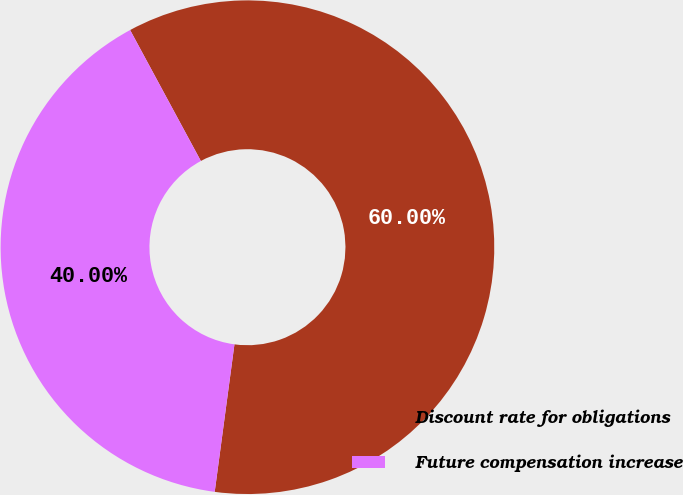<chart> <loc_0><loc_0><loc_500><loc_500><pie_chart><fcel>Discount rate for obligations<fcel>Future compensation increase<nl><fcel>60.0%<fcel>40.0%<nl></chart> 